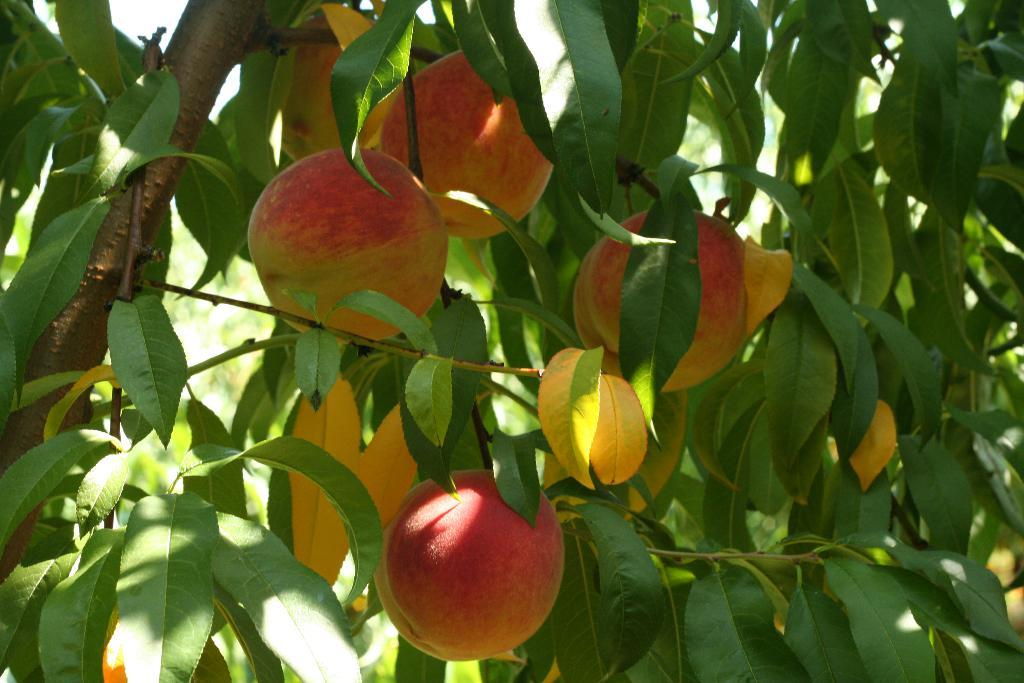What is the main subject of the image? The main subject of the image is a stem with leaves. What else can be seen in the image besides the stem with leaves? There are fruits in the image. How many ducks are connected to the stem in the image? There are no ducks present in the image, and the stem is not connected to any ducks. 